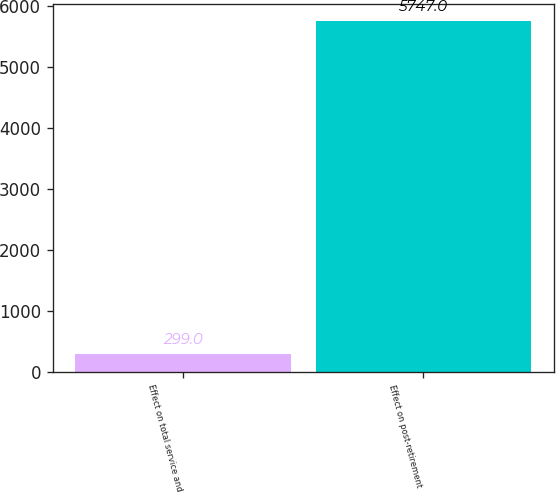Convert chart. <chart><loc_0><loc_0><loc_500><loc_500><bar_chart><fcel>Effect on total service and<fcel>Effect on post-retirement<nl><fcel>299<fcel>5747<nl></chart> 